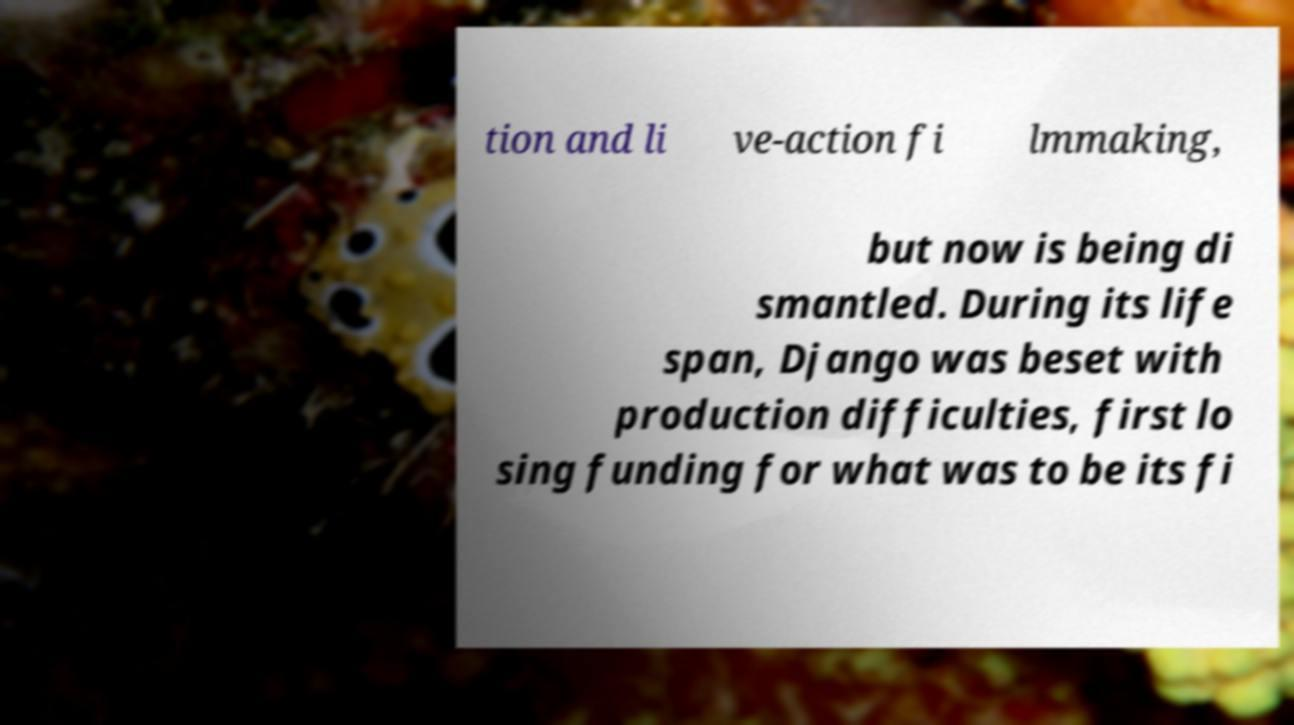Can you read and provide the text displayed in the image?This photo seems to have some interesting text. Can you extract and type it out for me? tion and li ve-action fi lmmaking, but now is being di smantled. During its life span, Django was beset with production difficulties, first lo sing funding for what was to be its fi 